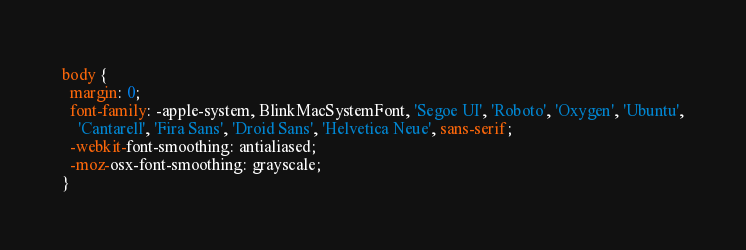Convert code to text. <code><loc_0><loc_0><loc_500><loc_500><_CSS_>body {
  margin: 0;
  font-family: -apple-system, BlinkMacSystemFont, 'Segoe UI', 'Roboto', 'Oxygen', 'Ubuntu',
    'Cantarell', 'Fira Sans', 'Droid Sans', 'Helvetica Neue', sans-serif;
  -webkit-font-smoothing: antialiased;
  -moz-osx-font-smoothing: grayscale;
}
</code> 